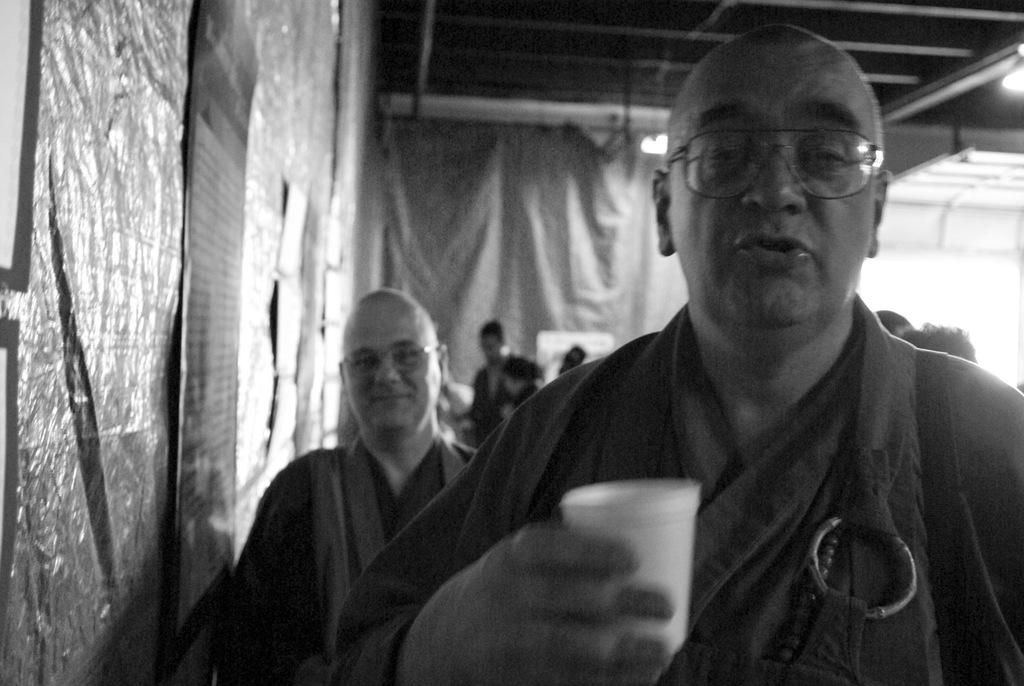How many people are in the image? There is a group of persons in the image. What is one person holding in the image? One person is holding a glass. What can be seen in the background of the image? There is a roof and lights visible in the background of the image. What type of grain is being harvested by the person holding the glass in the image? There is no grain or harvesting activity present in the image. 